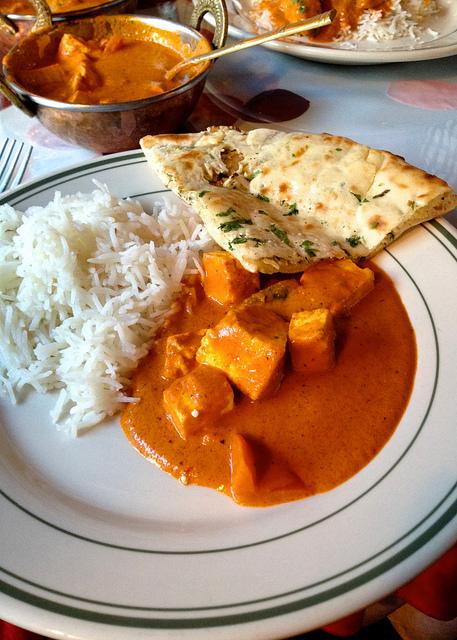What is the white stuff on the plate?
Answer briefly. Rice. Is the orange sauce carrot-based?
Be succinct. No. What country is this food from?
Keep it brief. India. 